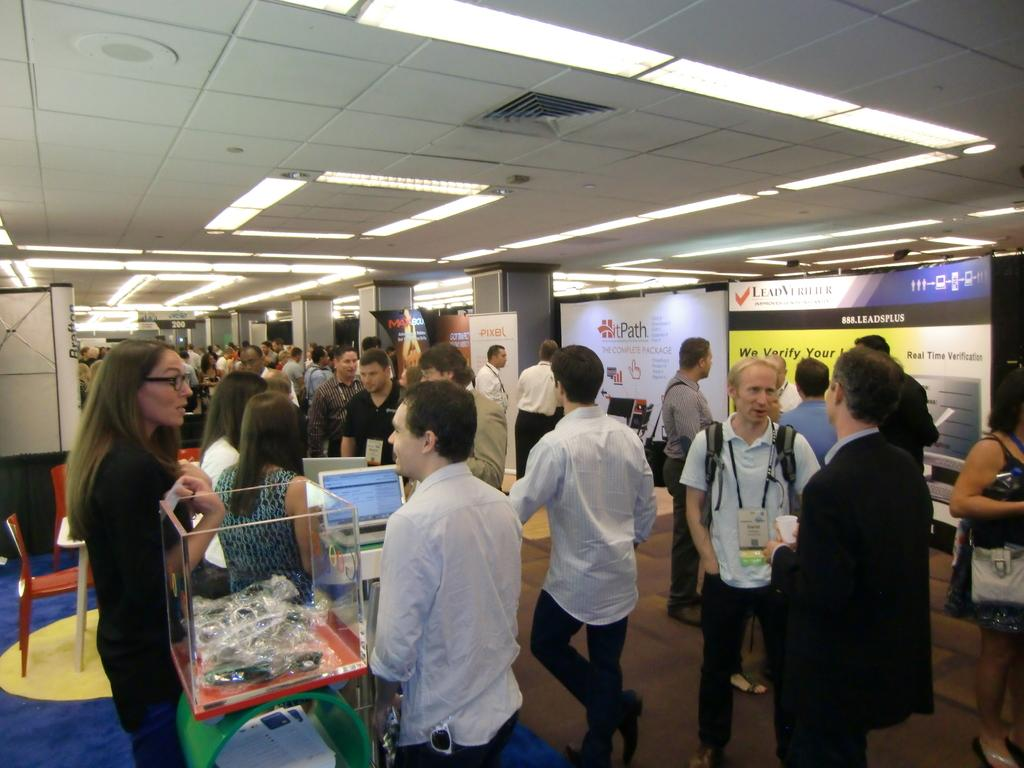How many people are in the image? There is a group of people standing in the image. What is the surface they are standing on? The people are standing on the floor. What can be seen in the background of the image? There is a hoarding in the image. Are there any furniture items visible? Yes, there is a chair in the image. What type of lighting is present in the image? There is a light in the image. What architectural feature can be seen in the image? There is a pillar in the image. What is the uppermost part of the structure in the image? There is a roof in the image. What type of design is featured on the rat in the image? There is no rat present in the image, so it is not possible to answer that question. 